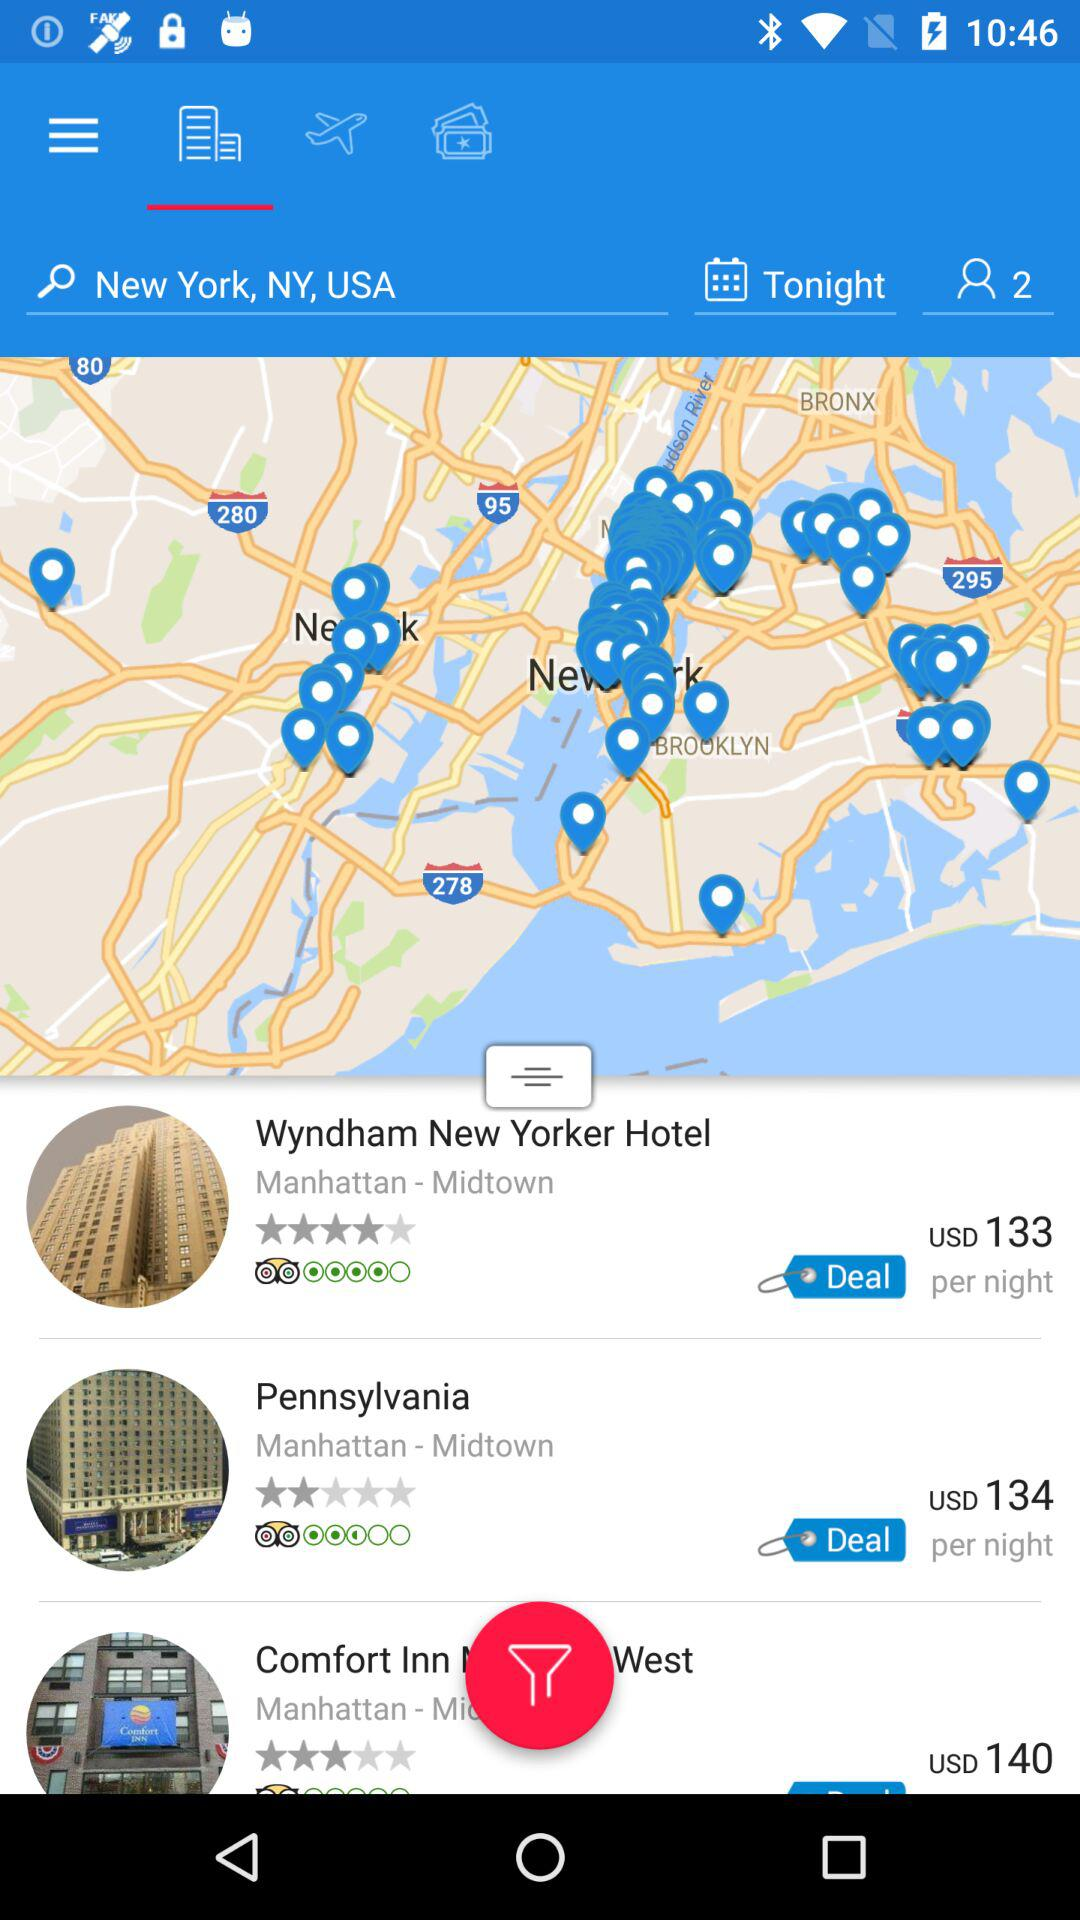What is the rating for the "Wyndham New Yorker Hotel"? The rating is 4 stars. 